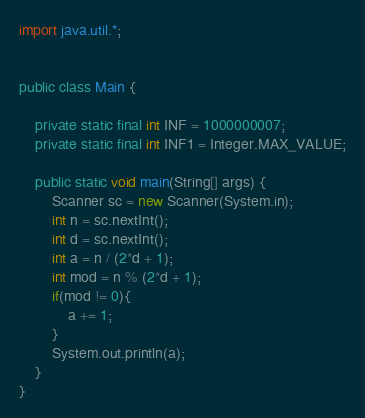<code> <loc_0><loc_0><loc_500><loc_500><_Java_>import java.util.*;


public class Main {

    private static final int INF = 1000000007;
    private static final int INF1 = Integer.MAX_VALUE;

    public static void main(String[] args) {
        Scanner sc = new Scanner(System.in);
        int n = sc.nextInt();
        int d = sc.nextInt();
        int a = n / (2*d + 1);
        int mod = n % (2*d + 1);
        if(mod != 0){
            a += 1;
        }
        System.out.println(a);
    }
}
</code> 